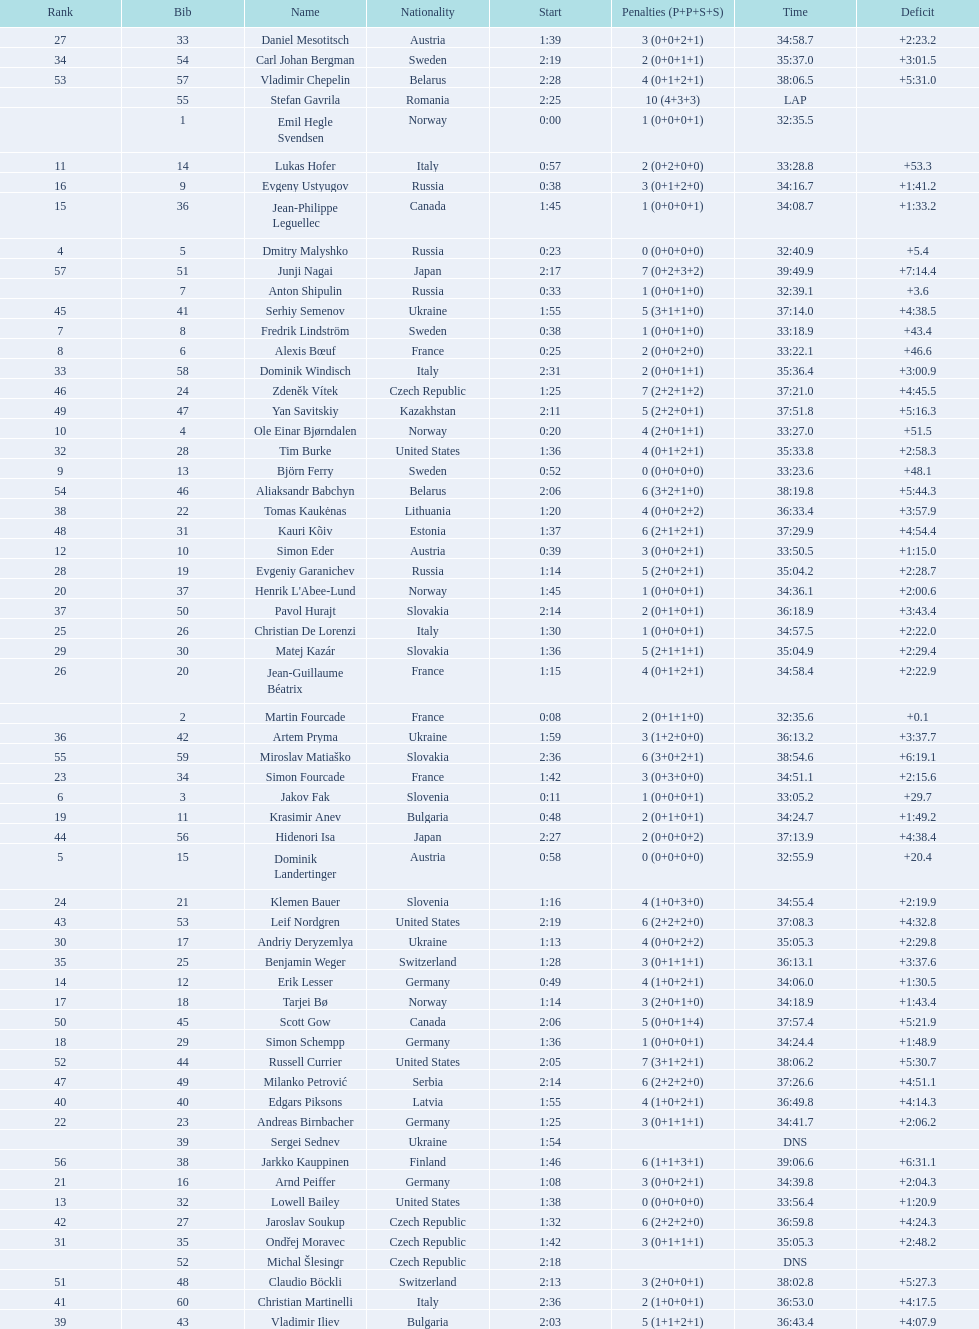What is the number of russian participants? 4. 